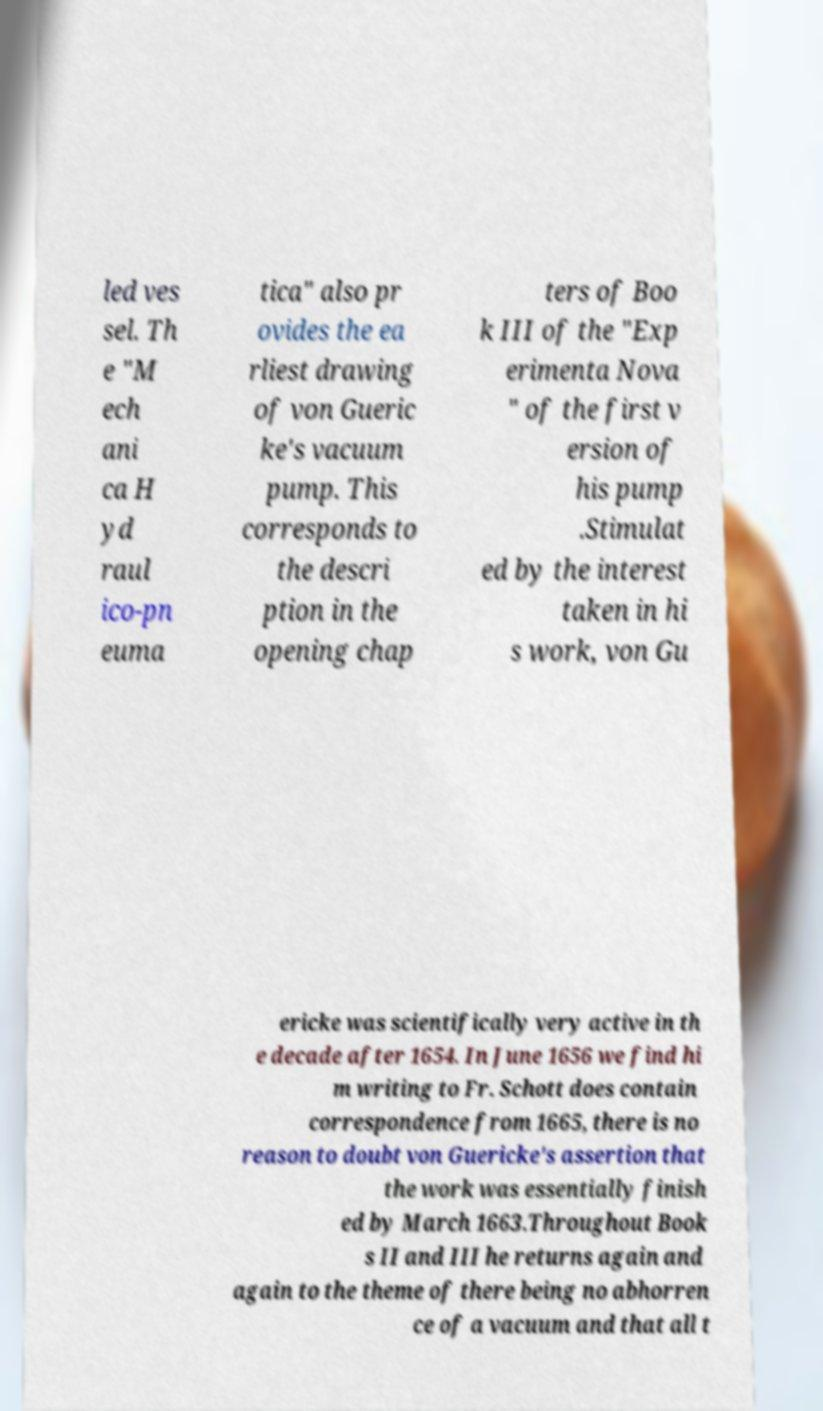There's text embedded in this image that I need extracted. Can you transcribe it verbatim? led ves sel. Th e "M ech ani ca H yd raul ico-pn euma tica" also pr ovides the ea rliest drawing of von Gueric ke's vacuum pump. This corresponds to the descri ption in the opening chap ters of Boo k III of the "Exp erimenta Nova " of the first v ersion of his pump .Stimulat ed by the interest taken in hi s work, von Gu ericke was scientifically very active in th e decade after 1654. In June 1656 we find hi m writing to Fr. Schott does contain correspondence from 1665, there is no reason to doubt von Guericke's assertion that the work was essentially finish ed by March 1663.Throughout Book s II and III he returns again and again to the theme of there being no abhorren ce of a vacuum and that all t 